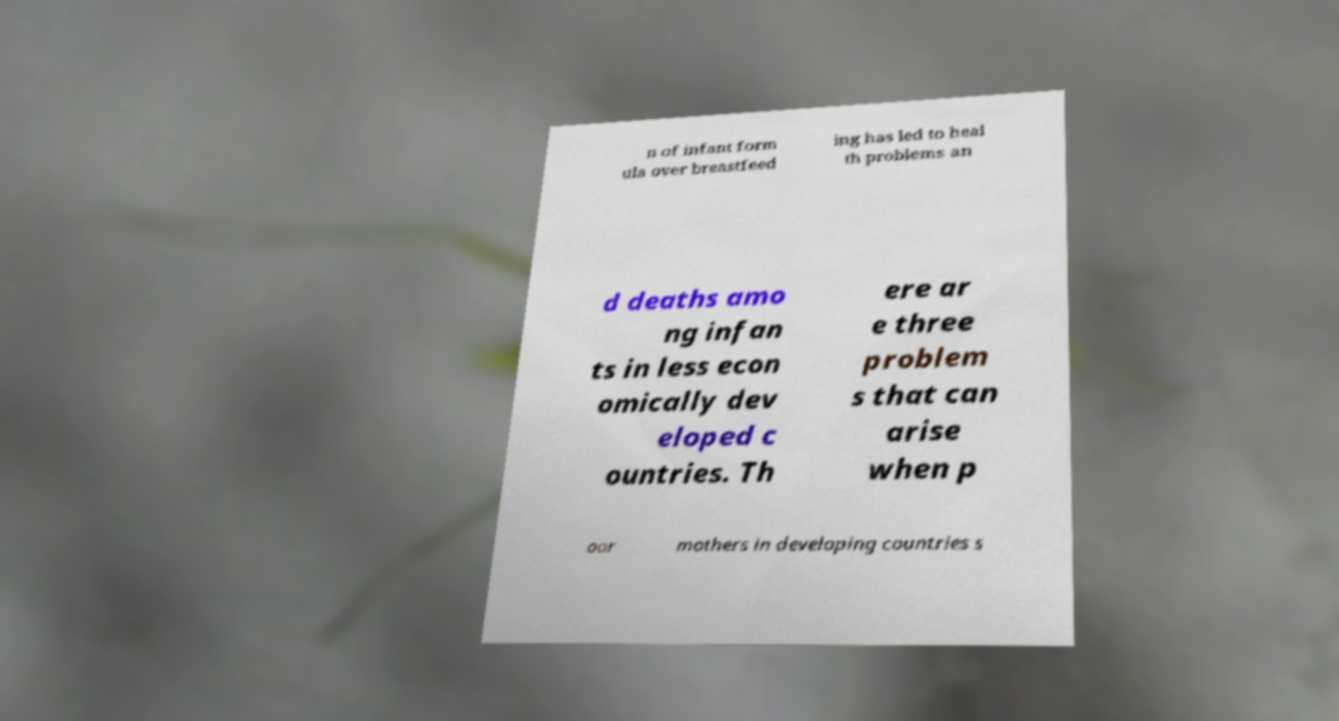Could you extract and type out the text from this image? n of infant form ula over breastfeed ing has led to heal th problems an d deaths amo ng infan ts in less econ omically dev eloped c ountries. Th ere ar e three problem s that can arise when p oor mothers in developing countries s 